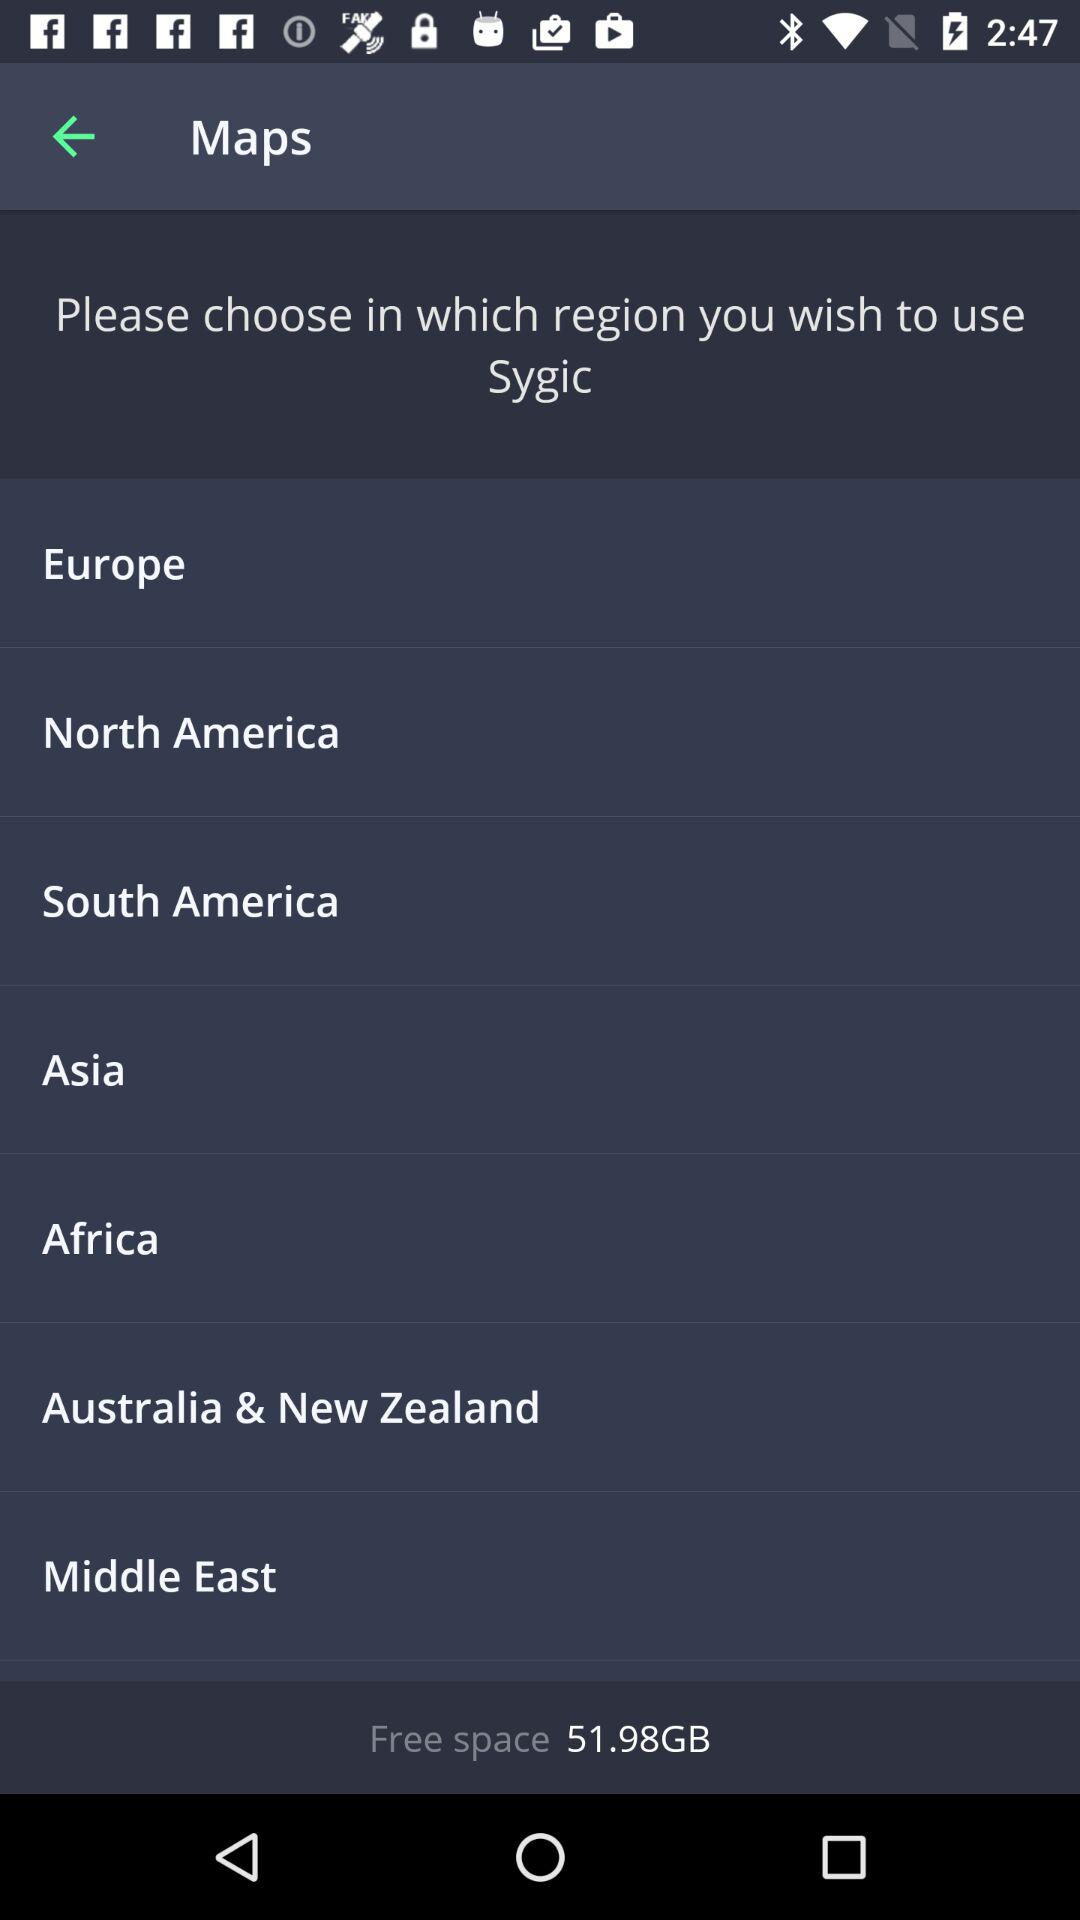What navigation regions are offered in this application? The application provides navigation for several regions, including Europe, North America, South America, Asia, Africa, Australia & New Zealand, and the Middle East. 